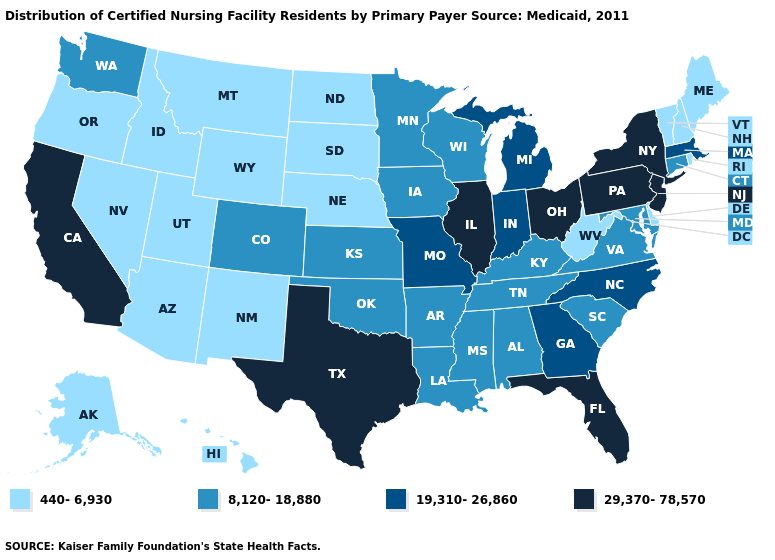Among the states that border Rhode Island , does Connecticut have the lowest value?
Keep it brief. Yes. What is the value of Pennsylvania?
Write a very short answer. 29,370-78,570. Does the first symbol in the legend represent the smallest category?
Concise answer only. Yes. What is the value of Washington?
Give a very brief answer. 8,120-18,880. Name the states that have a value in the range 440-6,930?
Quick response, please. Alaska, Arizona, Delaware, Hawaii, Idaho, Maine, Montana, Nebraska, Nevada, New Hampshire, New Mexico, North Dakota, Oregon, Rhode Island, South Dakota, Utah, Vermont, West Virginia, Wyoming. Does the map have missing data?
Answer briefly. No. Which states have the highest value in the USA?
Give a very brief answer. California, Florida, Illinois, New Jersey, New York, Ohio, Pennsylvania, Texas. What is the value of Montana?
Keep it brief. 440-6,930. Which states hav the highest value in the West?
Write a very short answer. California. What is the value of South Carolina?
Answer briefly. 8,120-18,880. Name the states that have a value in the range 8,120-18,880?
Concise answer only. Alabama, Arkansas, Colorado, Connecticut, Iowa, Kansas, Kentucky, Louisiana, Maryland, Minnesota, Mississippi, Oklahoma, South Carolina, Tennessee, Virginia, Washington, Wisconsin. What is the value of Missouri?
Quick response, please. 19,310-26,860. What is the value of New Jersey?
Write a very short answer. 29,370-78,570. Does the first symbol in the legend represent the smallest category?
Answer briefly. Yes. How many symbols are there in the legend?
Concise answer only. 4. 